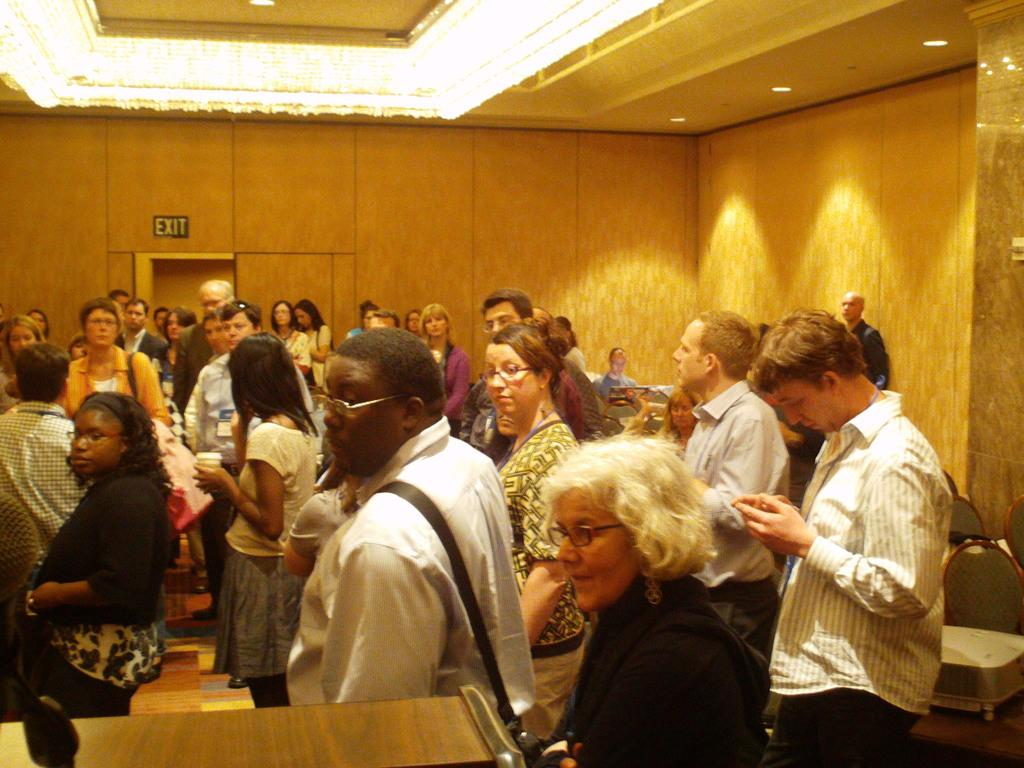How many individuals are present in the image? There are a lot of people in the image. What are the people in the image doing? The people are standing. Can you see a squirrel climbing a tree in the image? There is no squirrel or tree present in the image. What type of finger food is being served on a plate in the image? There is no plate or finger food present in the image. 